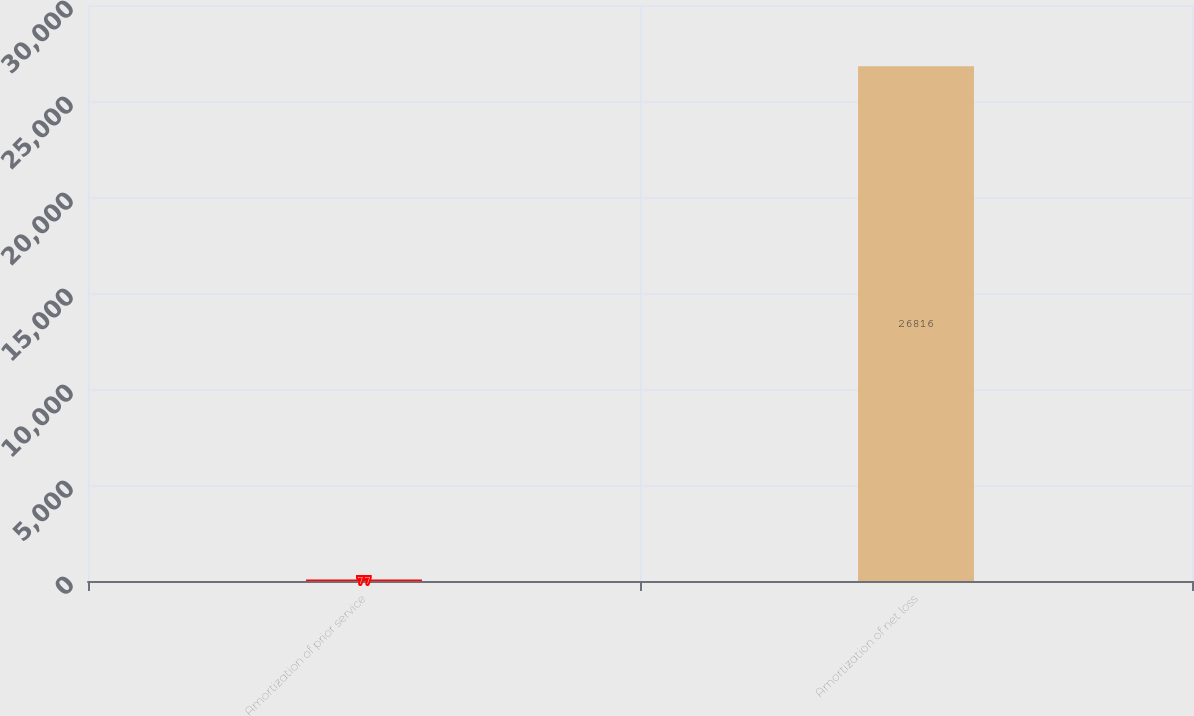Convert chart. <chart><loc_0><loc_0><loc_500><loc_500><bar_chart><fcel>Amortization of prior service<fcel>Amortization of net loss<nl><fcel>77<fcel>26816<nl></chart> 